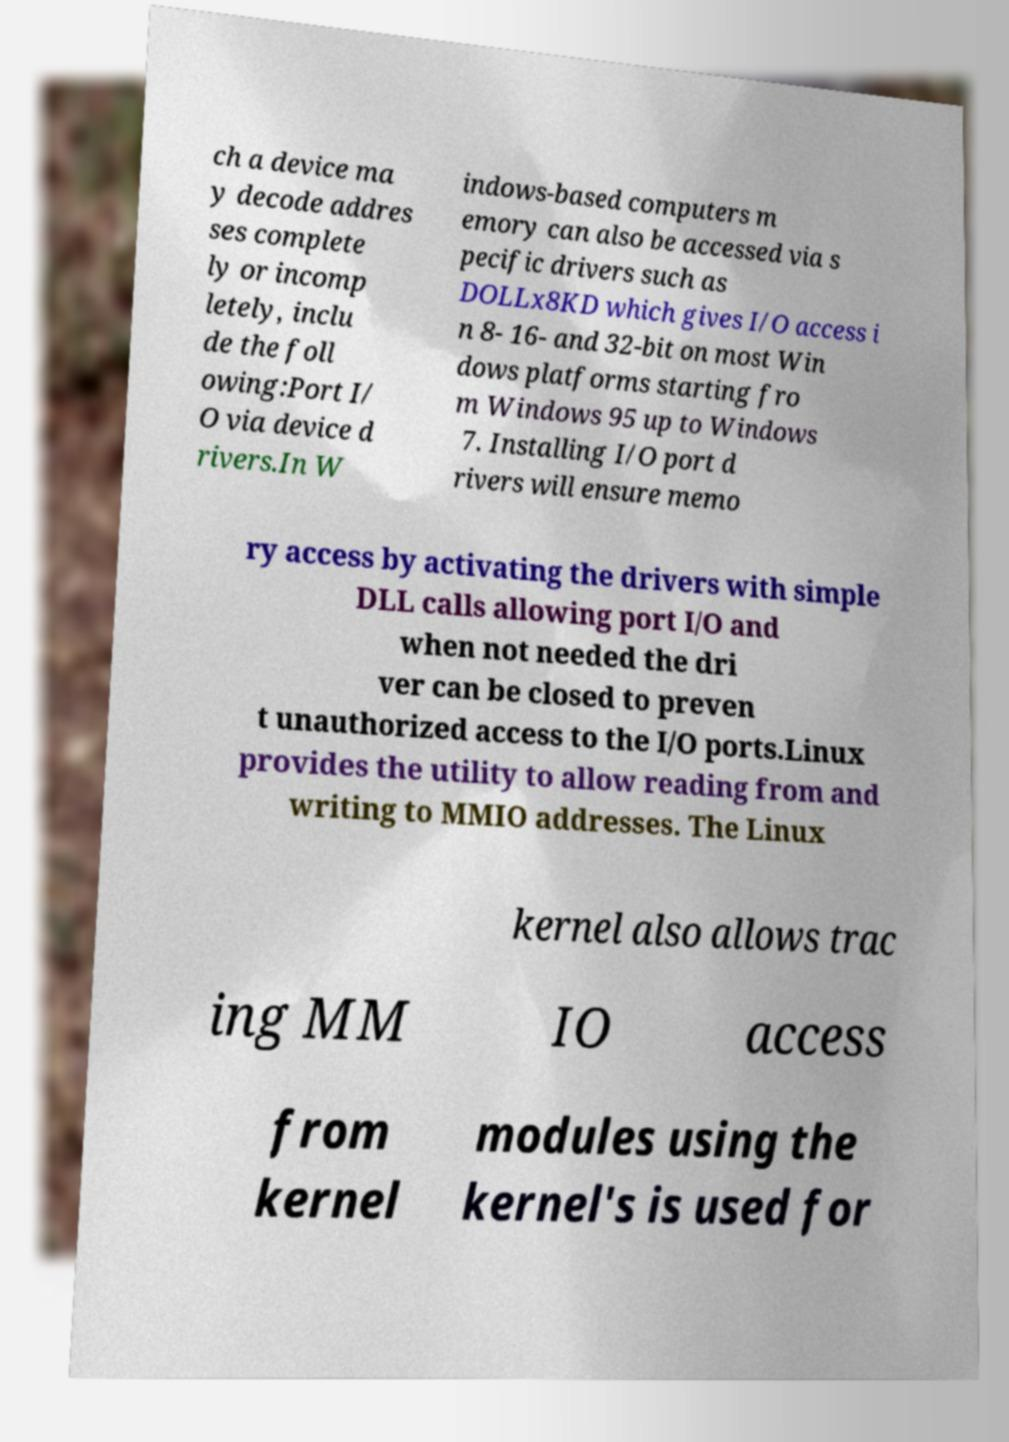Please identify and transcribe the text found in this image. ch a device ma y decode addres ses complete ly or incomp letely, inclu de the foll owing:Port I/ O via device d rivers.In W indows-based computers m emory can also be accessed via s pecific drivers such as DOLLx8KD which gives I/O access i n 8- 16- and 32-bit on most Win dows platforms starting fro m Windows 95 up to Windows 7. Installing I/O port d rivers will ensure memo ry access by activating the drivers with simple DLL calls allowing port I/O and when not needed the dri ver can be closed to preven t unauthorized access to the I/O ports.Linux provides the utility to allow reading from and writing to MMIO addresses. The Linux kernel also allows trac ing MM IO access from kernel modules using the kernel's is used for 